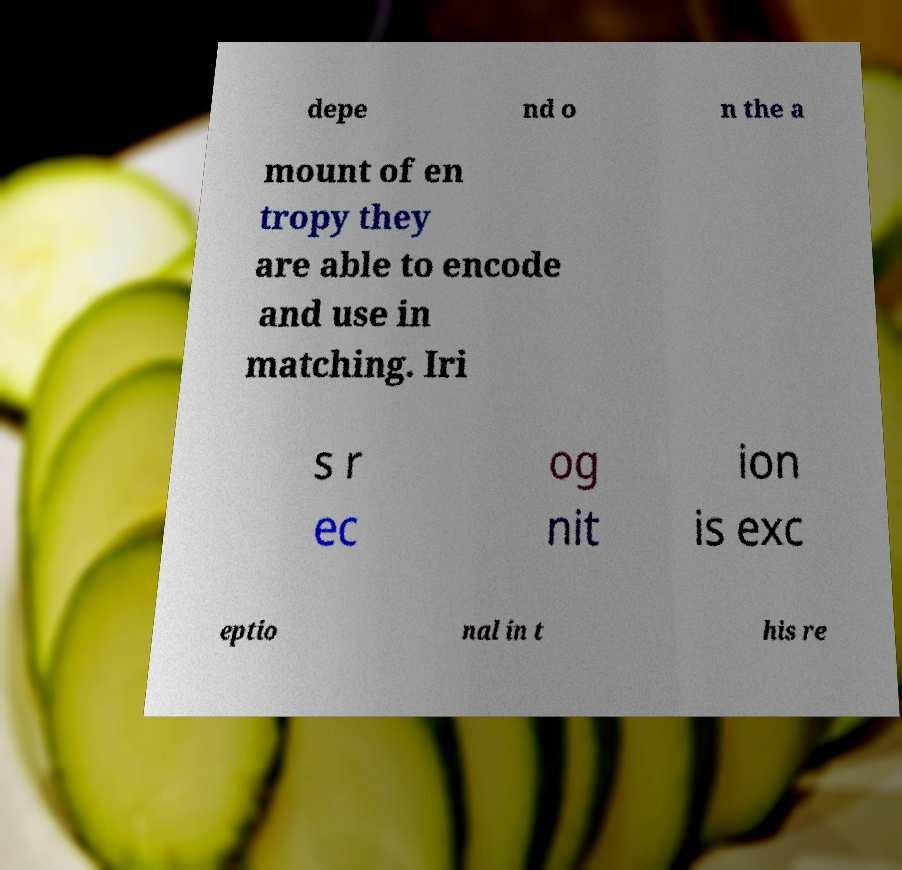Can you read and provide the text displayed in the image?This photo seems to have some interesting text. Can you extract and type it out for me? depe nd o n the a mount of en tropy they are able to encode and use in matching. Iri s r ec og nit ion is exc eptio nal in t his re 